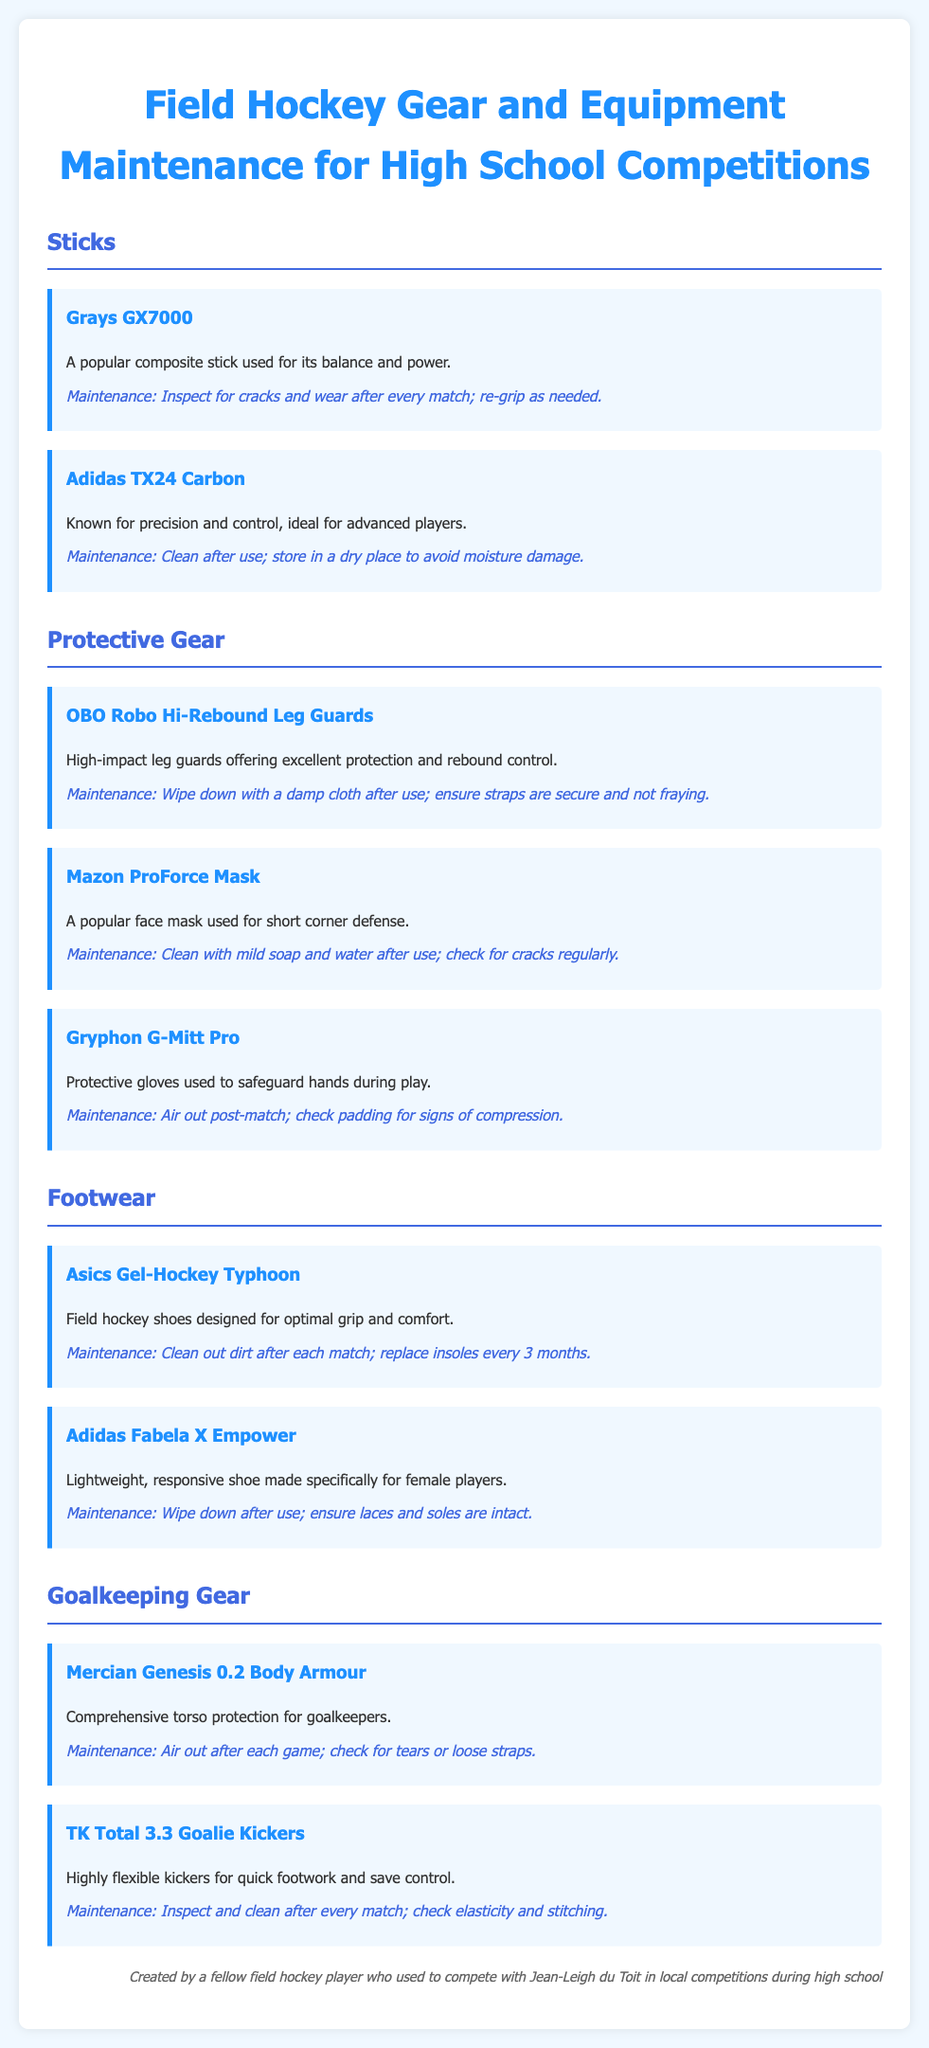what is a popular composite stick used for its balance and power? The document mentions the Grays GX7000 as a popular composite stick used for its balance and power.
Answer: Grays GX7000 which protective gear is used for short corner defense? According to the document, the Mazon ProForce Mask is a popular face mask used for short corner defense.
Answer: Mazon ProForce Mask how often should insoles be replaced for the Asics Gel-Hockey Typhoon shoes? The document states that insoles should be replaced every 3 months for the Asics Gel-Hockey Typhoon shoes.
Answer: every 3 months what is the maintenance suggestion for the OBO Robo Hi-Rebound Leg Guards? The document suggests wiping down the OBO Robo Hi-Rebound Leg Guards with a damp cloth after use and checking that the straps are secure.
Answer: Wipe down with a damp cloth; ensure straps are secure which brand offers highly flexible kickers for goalkeepers? The document mentions the TK brand for their Total 3.3 Goalie Kickers, which are highly flexible for quick footwork.
Answer: TK what type of footwear is designed specifically for female players? The document notes that the Adidas Fabela X Empower is a lightweight, responsive shoe made specifically for female players.
Answer: Adidas Fabela X Empower 